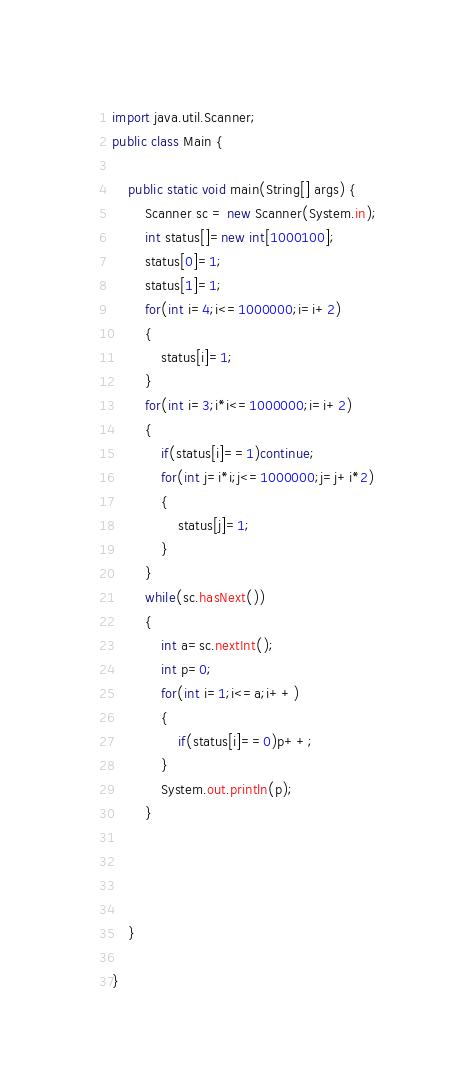<code> <loc_0><loc_0><loc_500><loc_500><_Java_>import java.util.Scanner;
public class Main {

	public static void main(String[] args) {
		Scanner sc = new Scanner(System.in);
		int status[]=new int[1000100];
		status[0]=1;
		status[1]=1;
		for(int i=4;i<=1000000;i=i+2)
		{
			status[i]=1;
		}
		for(int i=3;i*i<=1000000;i=i+2)
		{
			if(status[i]==1)continue;
			for(int j=i*i;j<=1000000;j=j+i*2)
			{
				status[j]=1;
			}
		}
		while(sc.hasNext())
		{
			int a=sc.nextInt();
			int p=0;
			for(int i=1;i<=a;i++)
			{
				if(status[i]==0)p++;
			}
			System.out.println(p);
		}
	
			
		

	}

}</code> 